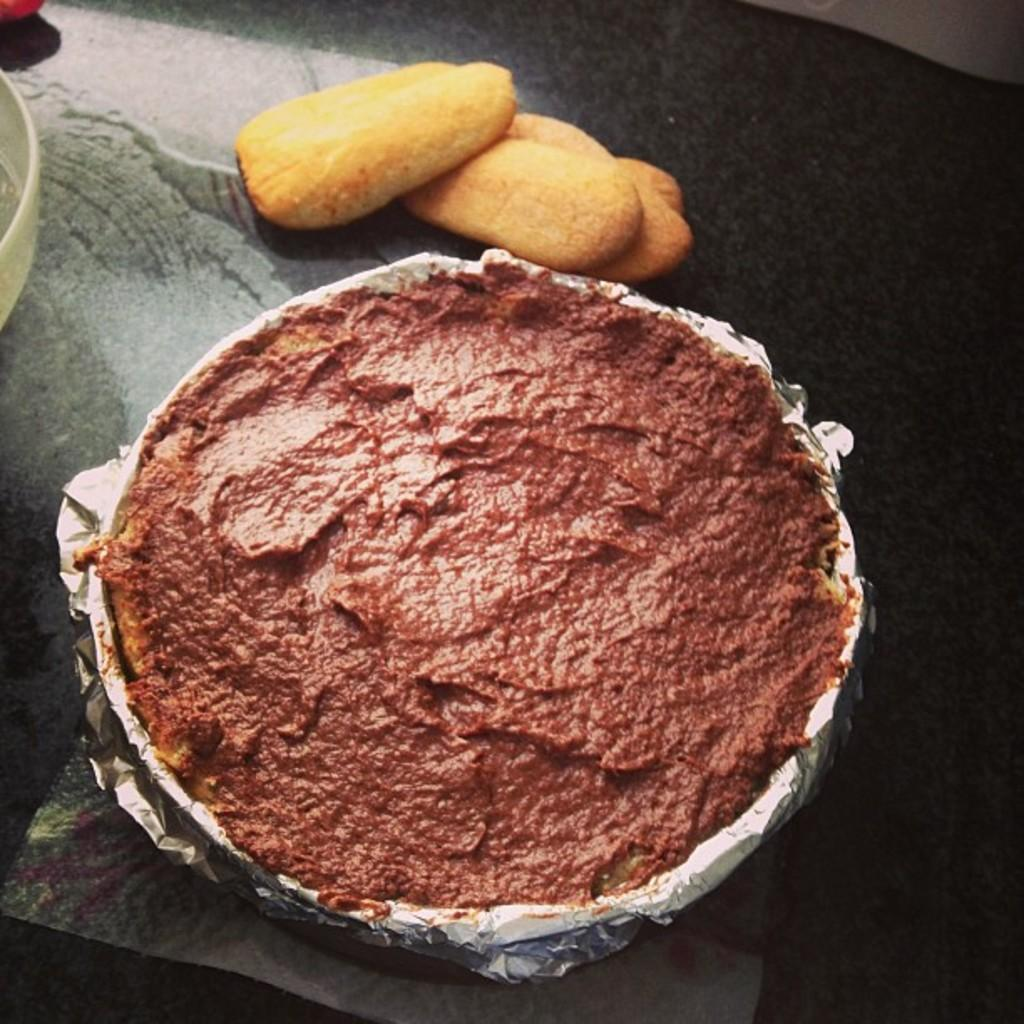What is the main subject of the image? There is a food item in a vessel in the image. Can you describe the food item in the vessel? Unfortunately, the specific food item cannot be determined from the given facts. What type of vessel is the food item in? The type of vessel cannot be determined from the given facts. What type of snow can be seen falling in the image? There is no mention of snow or any falling objects in the image, so it cannot be determined if snow is present. 